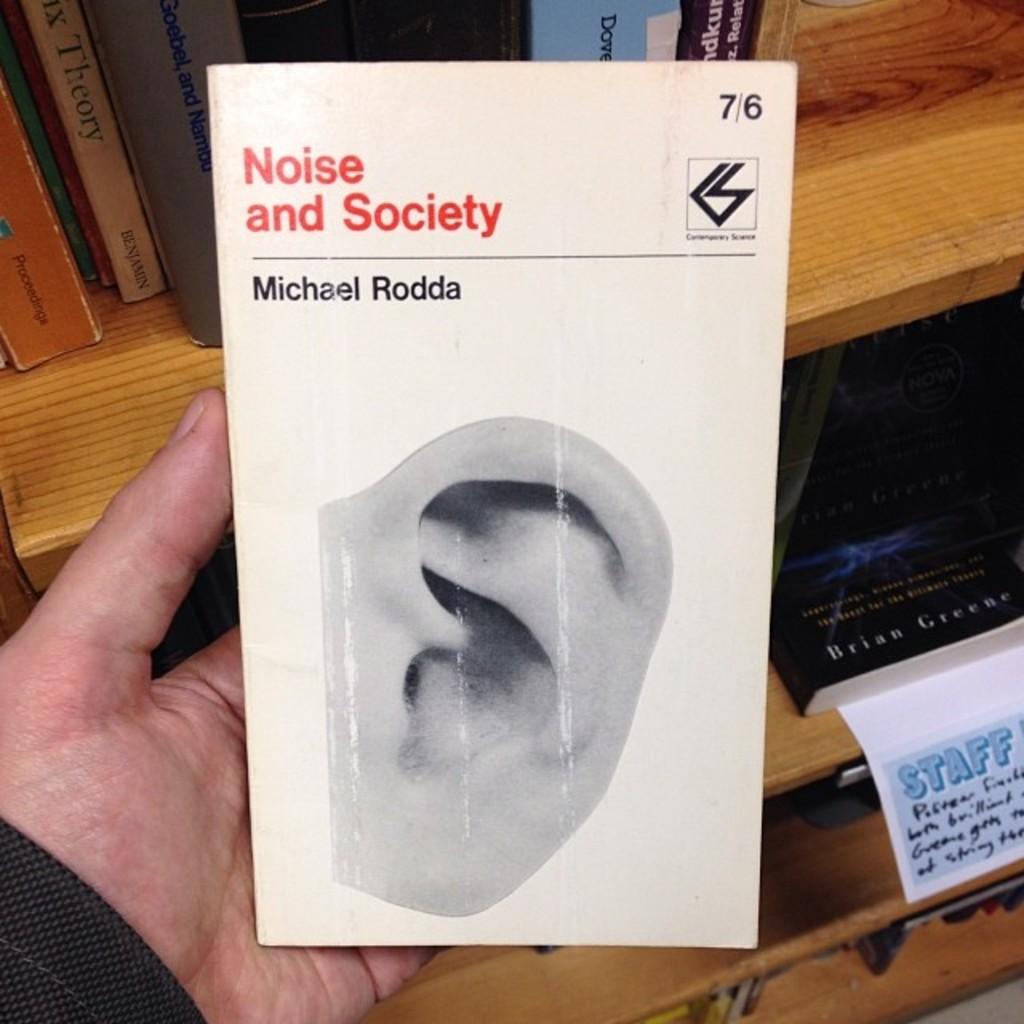Who are these books reserved for?
Your response must be concise. Staff. What are the numbers on the box?
Your response must be concise. 7/6. 